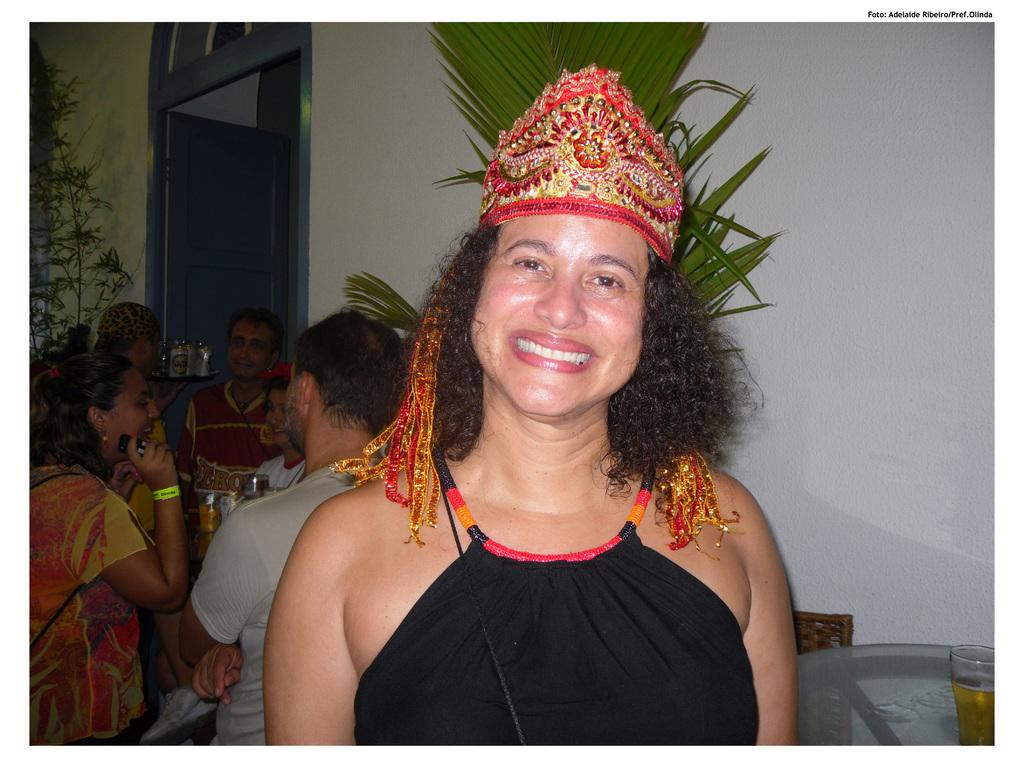What is the person in the image wearing on their head? There is a person with a crown in the image. How many people are present in the image? There are other people in the image besides the person with the crown. What type of vegetation can be seen in the image? There are plants in the image. What architectural feature is visible in the image? There is a door in the image. What is on the table in the image? There is a glass with a drink on a table in the image. What is the background of the image made of? There is a wall in the image. Can you see any fairies playing musical instruments in the image? There are no fairies or musical instruments present in the image. 